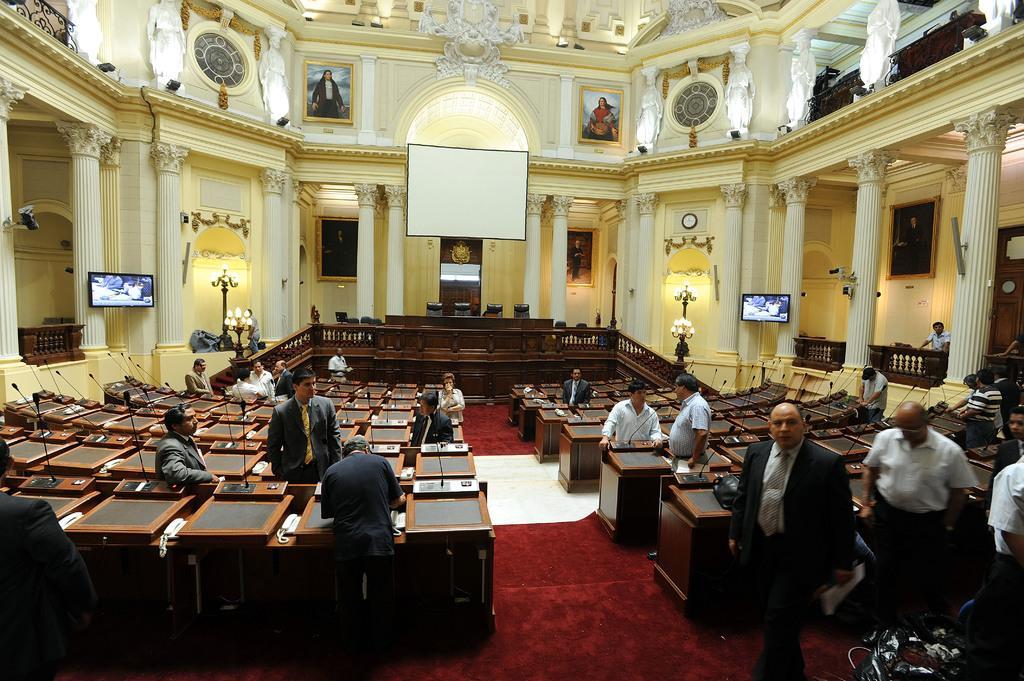How would you summarize this image in a sentence or two? In this image we can see the inside view of the building that includes podiums, lights, projector, people, floor mat and some other objects. 